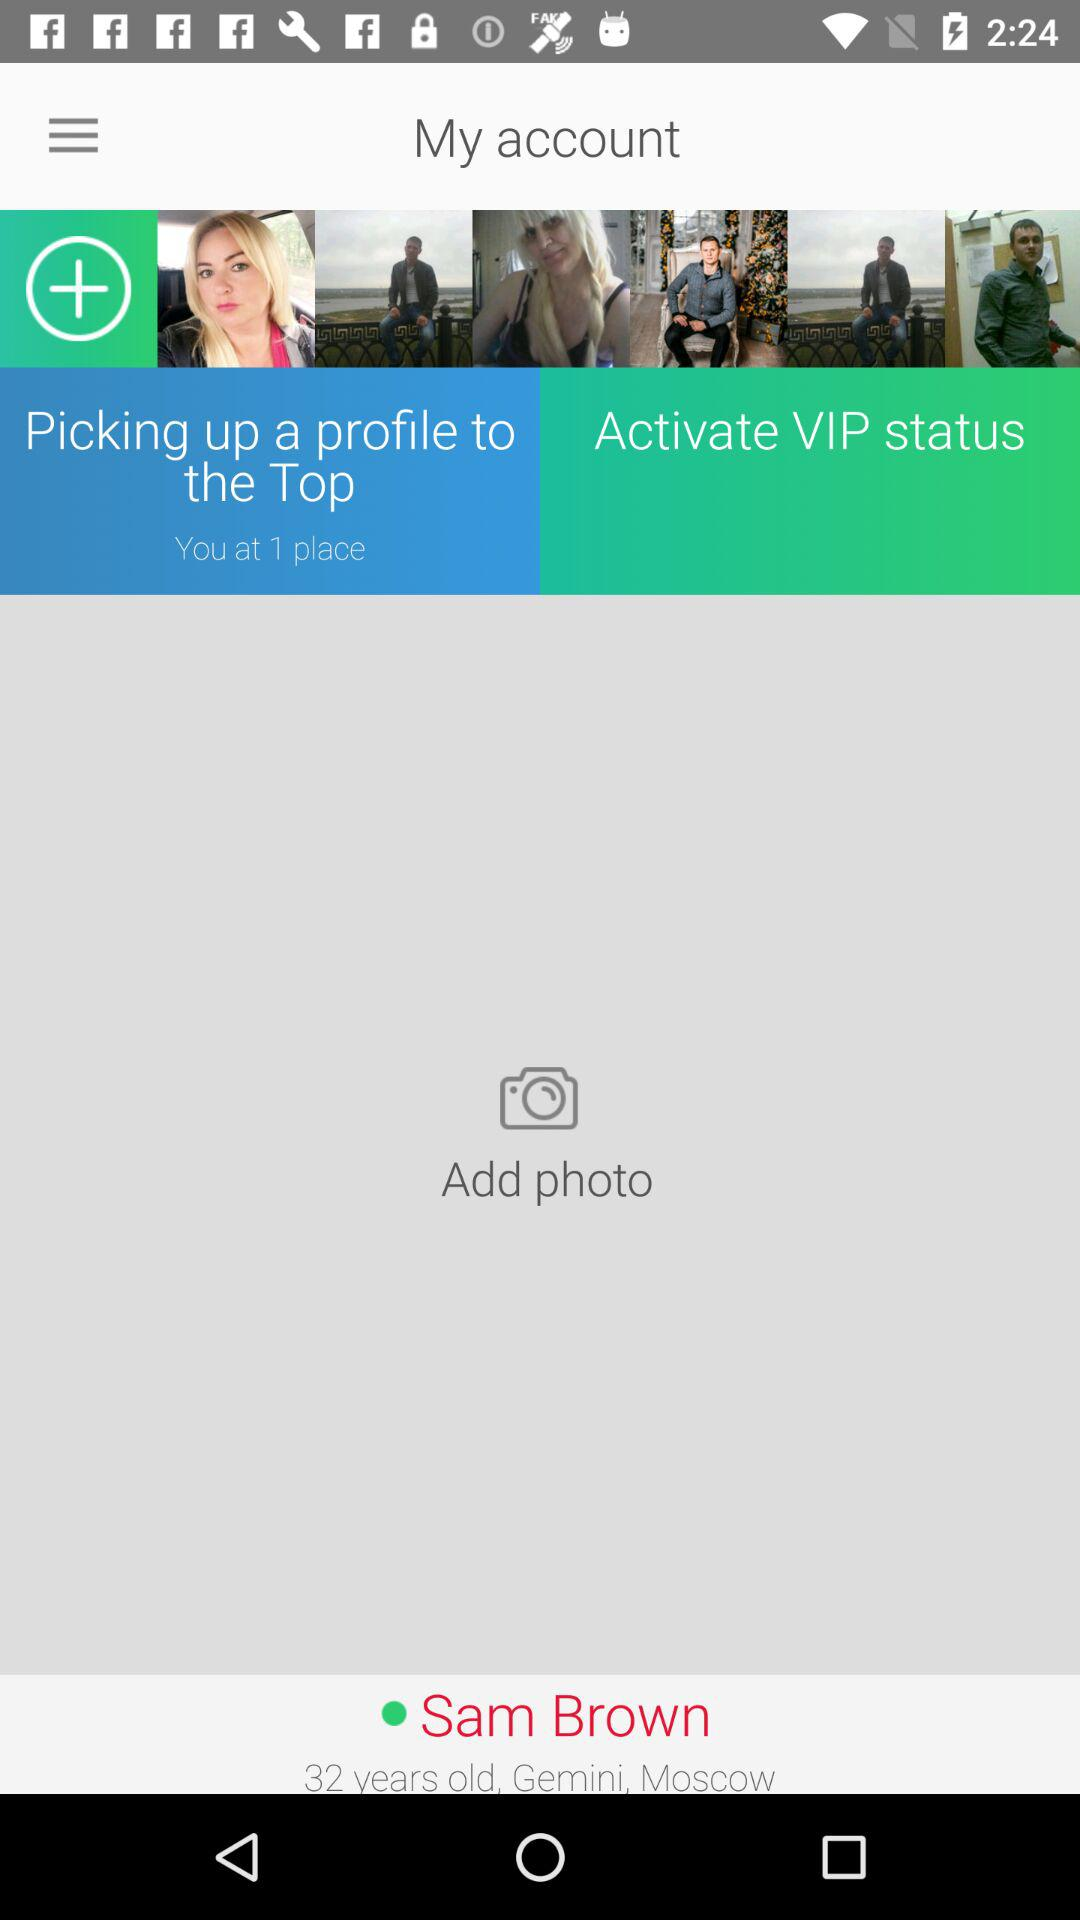What is the user's age? The user's age is 32. 